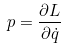Convert formula to latex. <formula><loc_0><loc_0><loc_500><loc_500>p = \frac { \partial L } { \partial \dot { q } }</formula> 